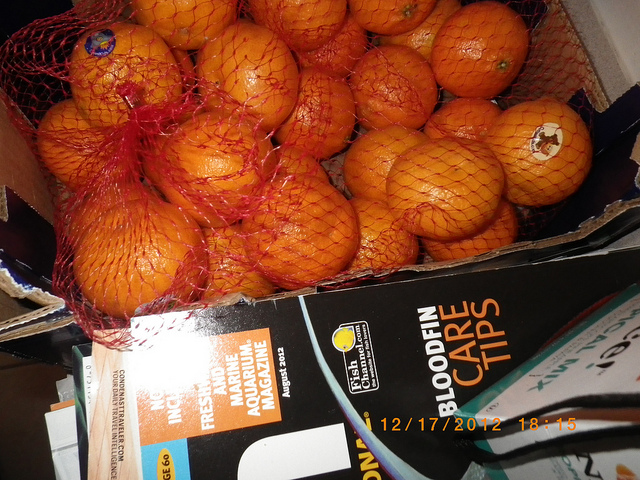<image>In what city was this fruit picked? It is unknown in what city this fruit was picked. In what city was this fruit picked? I am not sure in what city this fruit was picked. It could be any of 'tampa', 'austin', 'unknown', 'mexico', 'orlando', 'sacramento', 'san joaquin valley' or 'no idea'. 